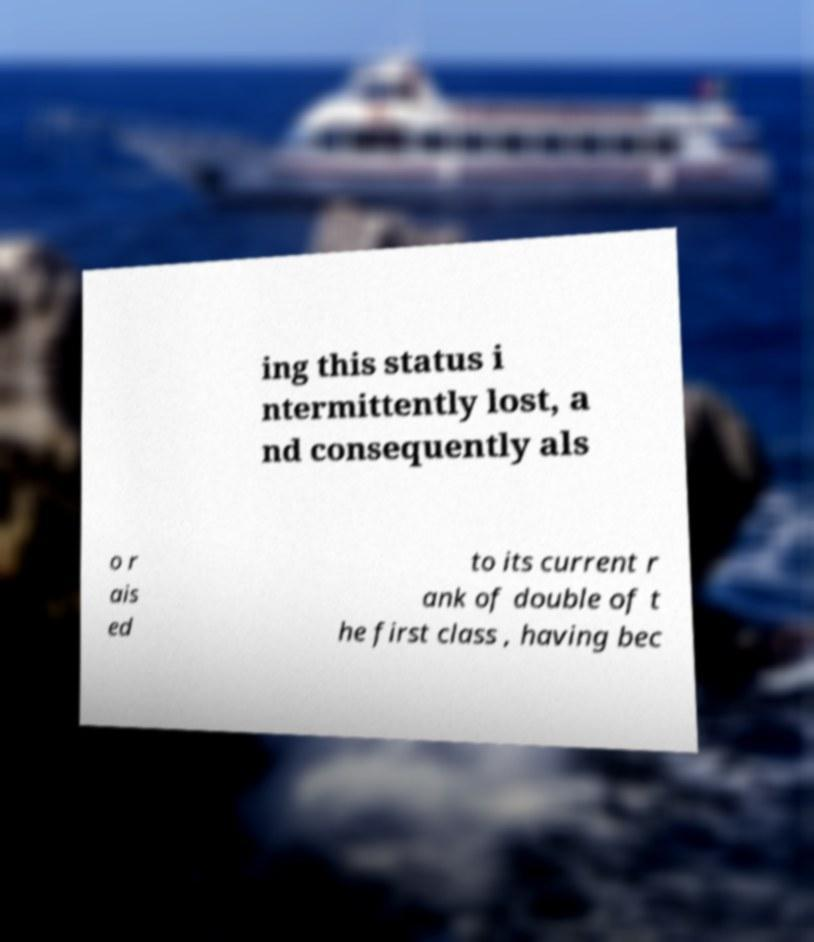Please identify and transcribe the text found in this image. ing this status i ntermittently lost, a nd consequently als o r ais ed to its current r ank of double of t he first class , having bec 